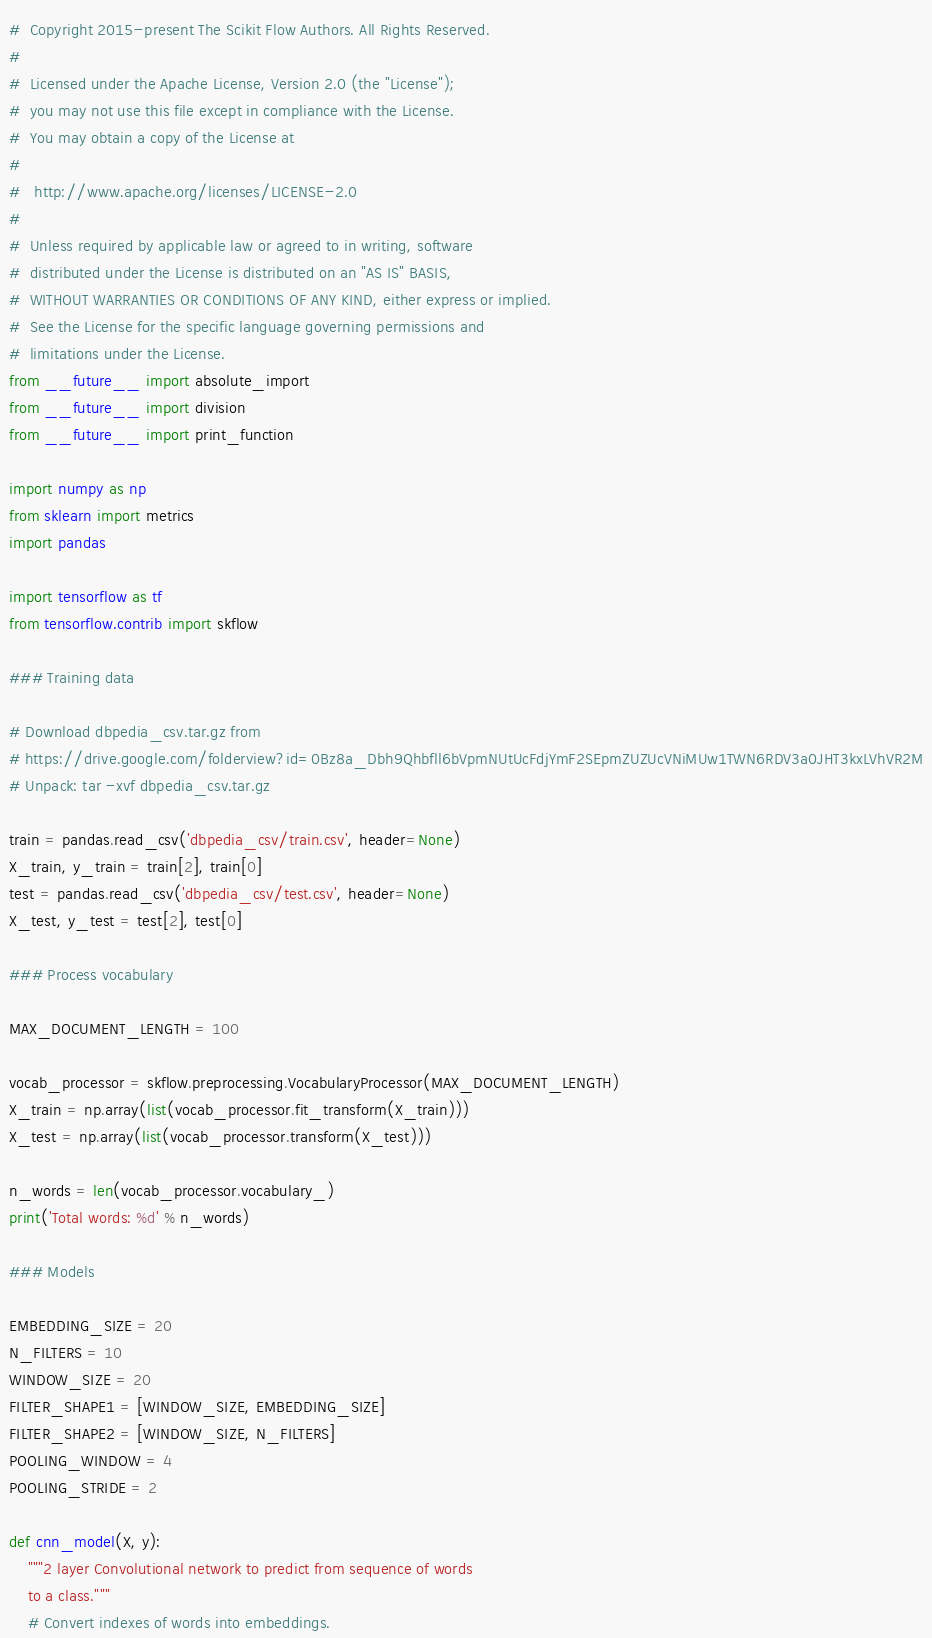Convert code to text. <code><loc_0><loc_0><loc_500><loc_500><_Python_>#  Copyright 2015-present The Scikit Flow Authors. All Rights Reserved.
#
#  Licensed under the Apache License, Version 2.0 (the "License");
#  you may not use this file except in compliance with the License.
#  You may obtain a copy of the License at
#
#   http://www.apache.org/licenses/LICENSE-2.0
#
#  Unless required by applicable law or agreed to in writing, software
#  distributed under the License is distributed on an "AS IS" BASIS,
#  WITHOUT WARRANTIES OR CONDITIONS OF ANY KIND, either express or implied.
#  See the License for the specific language governing permissions and
#  limitations under the License.
from __future__ import absolute_import
from __future__ import division
from __future__ import print_function

import numpy as np
from sklearn import metrics
import pandas

import tensorflow as tf
from tensorflow.contrib import skflow

### Training data

# Download dbpedia_csv.tar.gz from
# https://drive.google.com/folderview?id=0Bz8a_Dbh9Qhbfll6bVpmNUtUcFdjYmF2SEpmZUZUcVNiMUw1TWN6RDV3a0JHT3kxLVhVR2M
# Unpack: tar -xvf dbpedia_csv.tar.gz

train = pandas.read_csv('dbpedia_csv/train.csv', header=None)
X_train, y_train = train[2], train[0]
test = pandas.read_csv('dbpedia_csv/test.csv', header=None)
X_test, y_test = test[2], test[0]

### Process vocabulary

MAX_DOCUMENT_LENGTH = 100

vocab_processor = skflow.preprocessing.VocabularyProcessor(MAX_DOCUMENT_LENGTH)
X_train = np.array(list(vocab_processor.fit_transform(X_train)))
X_test = np.array(list(vocab_processor.transform(X_test)))

n_words = len(vocab_processor.vocabulary_)
print('Total words: %d' % n_words)

### Models

EMBEDDING_SIZE = 20
N_FILTERS = 10
WINDOW_SIZE = 20
FILTER_SHAPE1 = [WINDOW_SIZE, EMBEDDING_SIZE]
FILTER_SHAPE2 = [WINDOW_SIZE, N_FILTERS]
POOLING_WINDOW = 4
POOLING_STRIDE = 2

def cnn_model(X, y):
    """2 layer Convolutional network to predict from sequence of words
    to a class."""
    # Convert indexes of words into embeddings.</code> 